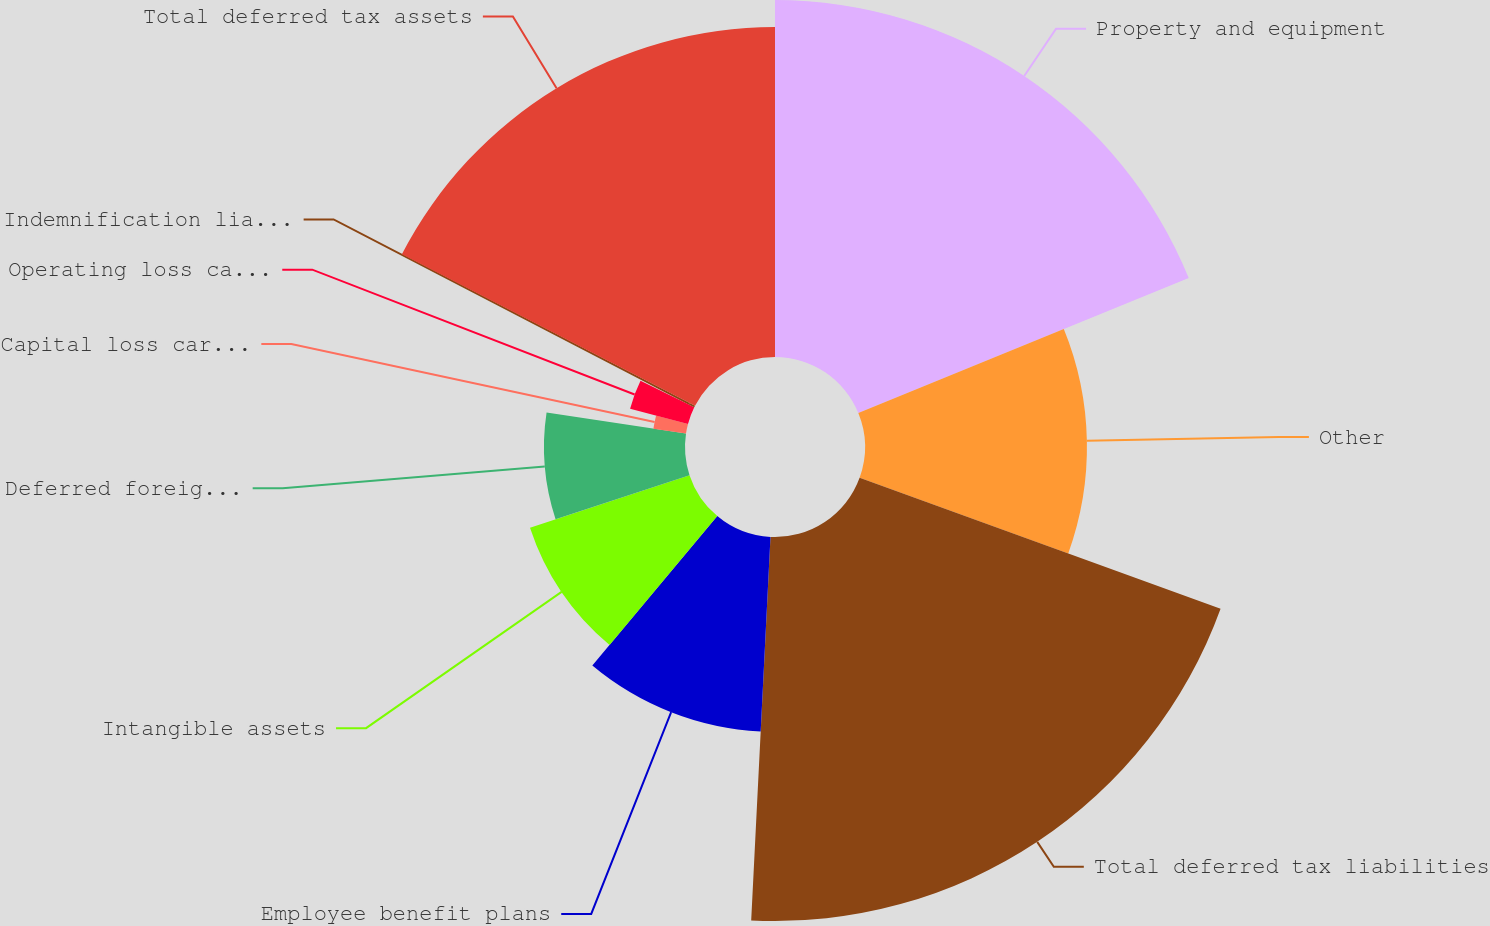<chart> <loc_0><loc_0><loc_500><loc_500><pie_chart><fcel>Property and equipment<fcel>Other<fcel>Total deferred tax liabilities<fcel>Employee benefit plans<fcel>Intangible assets<fcel>Deferred foreign tax credits<fcel>Capital loss carryforwards<fcel>Operating loss carryforwards<fcel>Indemnification liabilities<fcel>Total deferred tax assets<nl><fcel>18.83%<fcel>11.71%<fcel>20.26%<fcel>10.28%<fcel>8.86%<fcel>7.44%<fcel>1.74%<fcel>3.16%<fcel>0.31%<fcel>17.41%<nl></chart> 